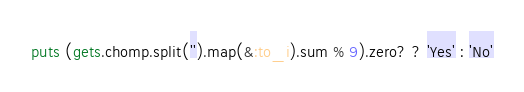Convert code to text. <code><loc_0><loc_0><loc_500><loc_500><_Ruby_>puts (gets.chomp.split('').map(&:to_i).sum % 9).zero? ? 'Yes' : 'No'</code> 